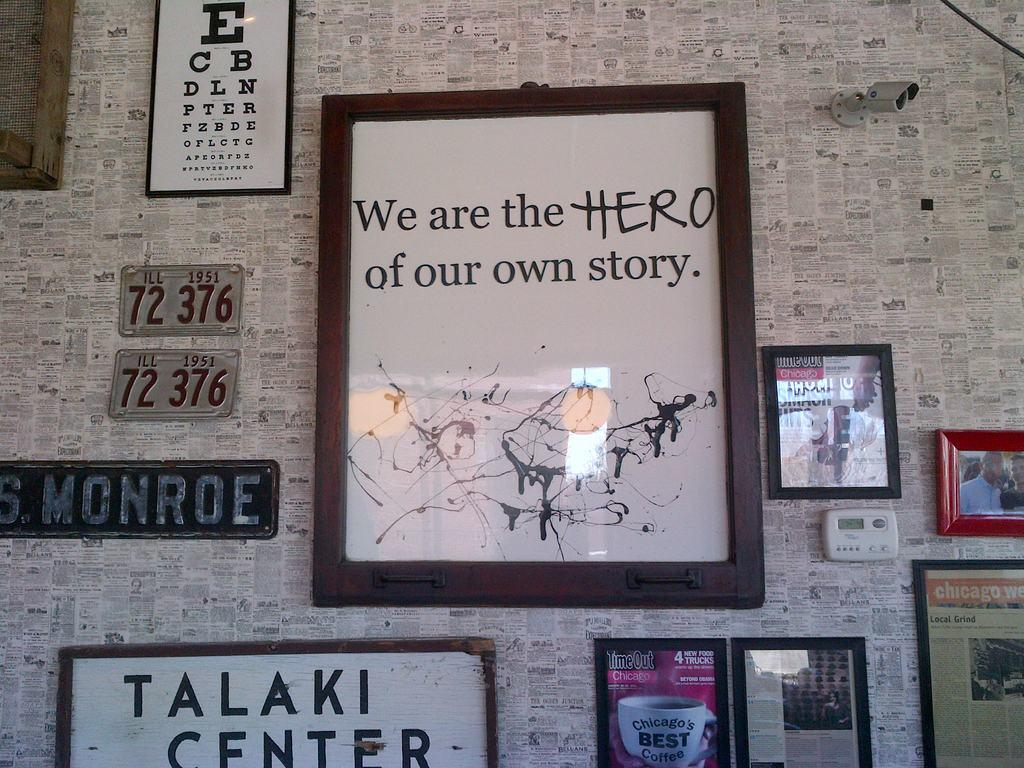<image>
Describe the image concisely. A framed poster that reads we are the hero of our own story. 